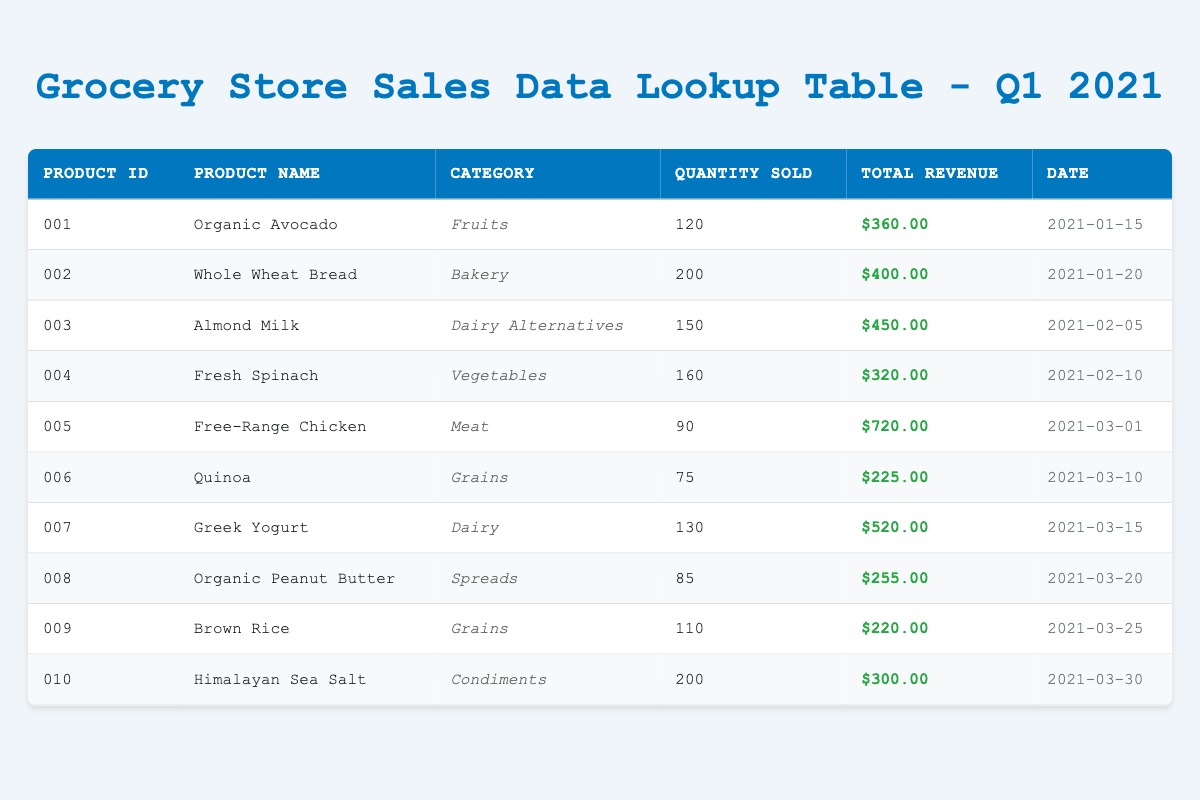What is the total revenue from the "Dairy" category? In the table, the only product listed under the "Dairy" category is Greek Yogurt, which has a total revenue of $520.00.
Answer: $520.00 How many units of "Whole Wheat Bread" were sold? The table shows that the quantity sold for "Whole Wheat Bread" is listed as 200 in the "Quantity Sold" column.
Answer: 200 Is there any product in the "Spreads" category that sold more than 100 units? The table lists Organic Peanut Butter in the "Spreads" category with a quantity sold of 85, which is not more than 100. Therefore, there are no products with more than 100 units sold in this category.
Answer: No What is the total revenue from "Grains"? The "Grains" category includes two products: Quinoa, with a total revenue of $225.00, and Brown Rice, with a total revenue of $220.00. Summing these gives $225.00 + $220.00 = $445.00.
Answer: $445.00 Which product had the highest revenue? By comparing the total revenue figures, Free-Range Chicken shows the highest total revenue of $720.00 among all products.
Answer: Free-Range Chicken How many more units were sold of "Fresh Spinach" compared to "Quinoa"? Fresh Spinach sold 160 units and Quinoa sold 75 units. The difference is 160 - 75 = 85 units.
Answer: 85 Did "Organic Avocado" generate more revenue than "Himalayan Sea Salt"? Organic Avocado generated $360.00 while Himalayan Sea Salt generated $300.00. Since 360.00 is greater than 300.00, the statement is true.
Answer: Yes What is the average quantity sold across all products? The total quantity sold across all products is 120 + 200 + 150 + 160 + 90 + 75 + 130 + 85 + 110 + 200 = 1320 units. There are 10 products, so the average is 1320 / 10 = 132.
Answer: 132 Which categories have products that sold less than 100 units? In the table, only Quinoa (75 units), and Organic Peanut Butter (85 units) fall below 100 units. They belong to the "Grains" and "Spreads" categories respectively.
Answer: Grains and Spreads 